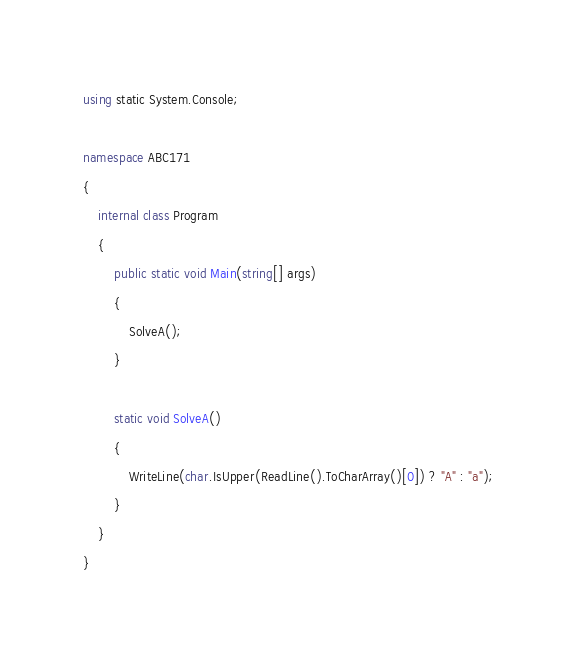<code> <loc_0><loc_0><loc_500><loc_500><_C#_>using static System.Console;

namespace ABC171
{
    internal class Program
    {
        public static void Main(string[] args)
        {
            SolveA();
        }

        static void SolveA()
        {
            WriteLine(char.IsUpper(ReadLine().ToCharArray()[0]) ? "A" : "a");
        }
    }
}</code> 